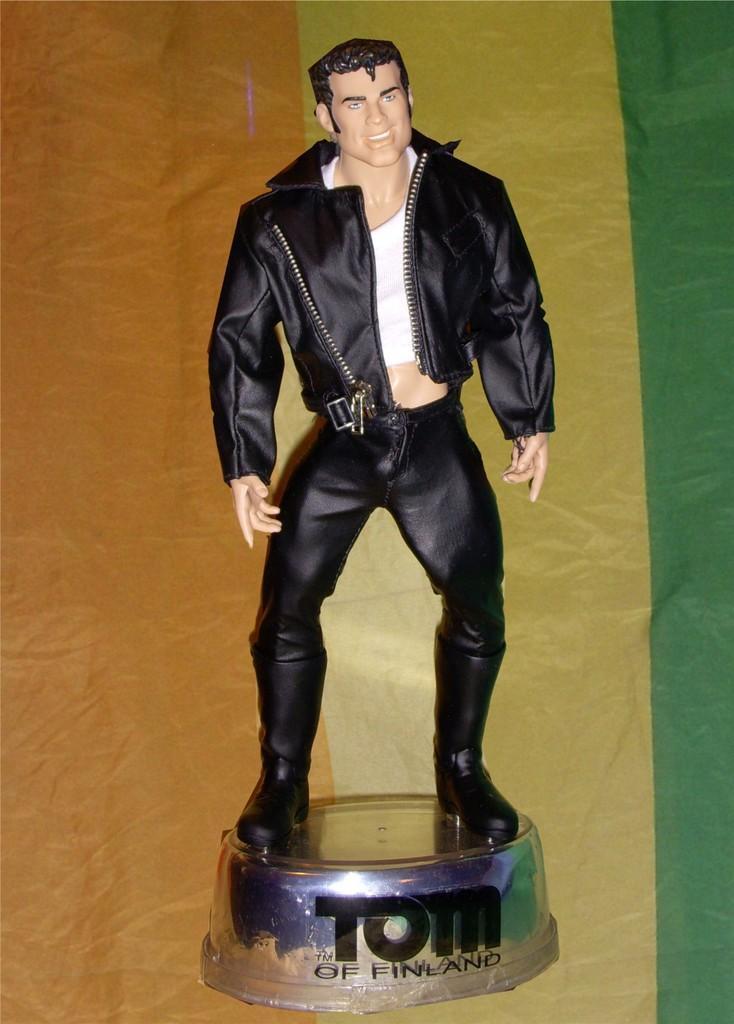Could you give a brief overview of what you see in this image? In the image there is a statue of a person on the round shape object. And also there is text on that object. Behind that state there are different colors. 